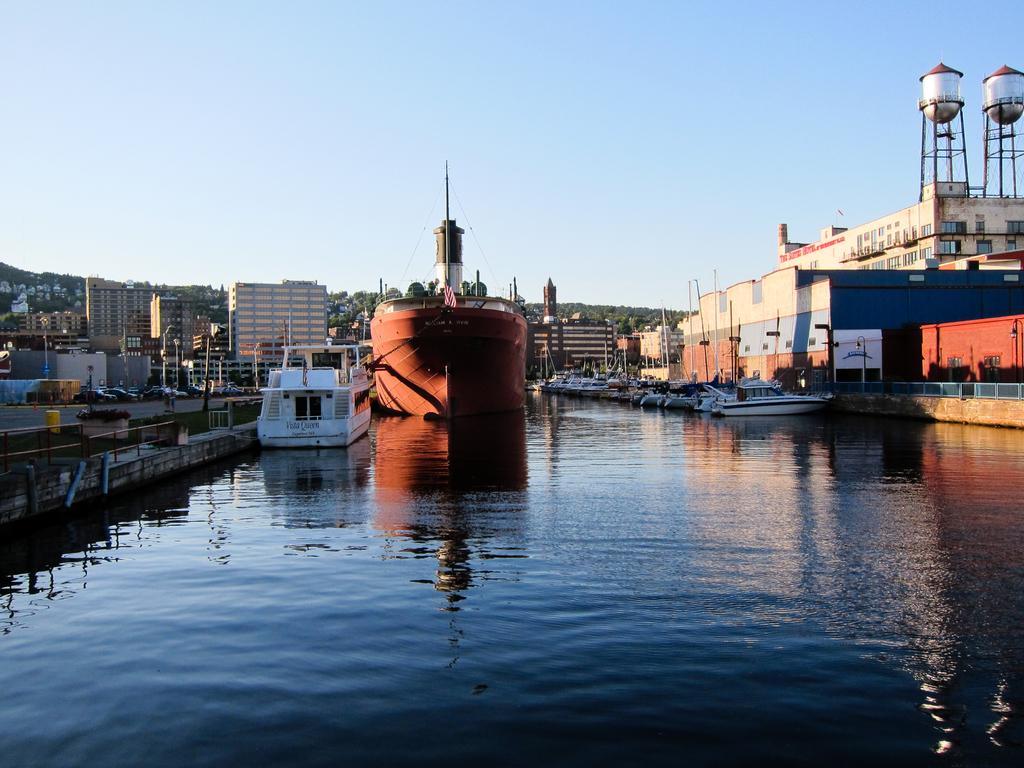In one or two sentences, can you explain what this image depicts? In this picture we can see a ship and boats on water, buildings, poles, grass, vehicles on the road, tanks and some objects and in the background we can see the sky. 